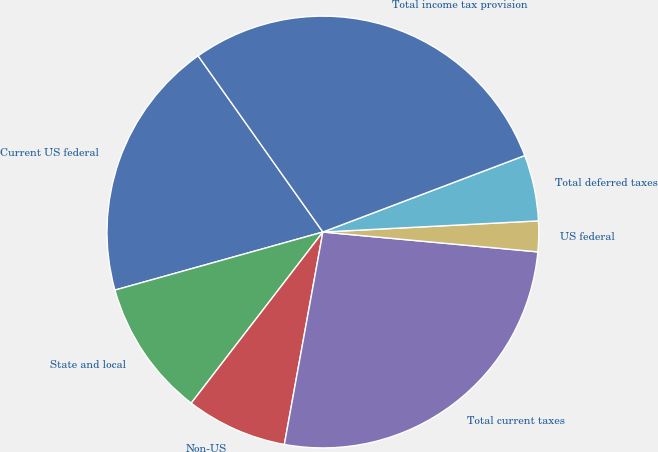Convert chart to OTSL. <chart><loc_0><loc_0><loc_500><loc_500><pie_chart><fcel>Current US federal<fcel>State and local<fcel>Non-US<fcel>Total current taxes<fcel>US federal<fcel>Total deferred taxes<fcel>Total income tax provision<nl><fcel>19.53%<fcel>10.23%<fcel>7.58%<fcel>26.39%<fcel>2.29%<fcel>4.94%<fcel>29.04%<nl></chart> 